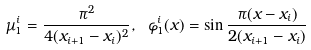<formula> <loc_0><loc_0><loc_500><loc_500>\mu _ { 1 } ^ { i } = \frac { \pi ^ { 2 } } { 4 ( x _ { i + 1 } - x _ { i } ) ^ { 2 } } , \ \varphi _ { 1 } ^ { i } ( x ) = \sin \frac { \pi ( x - x _ { i } ) } { 2 ( x _ { i + 1 } - x _ { i } ) }</formula> 